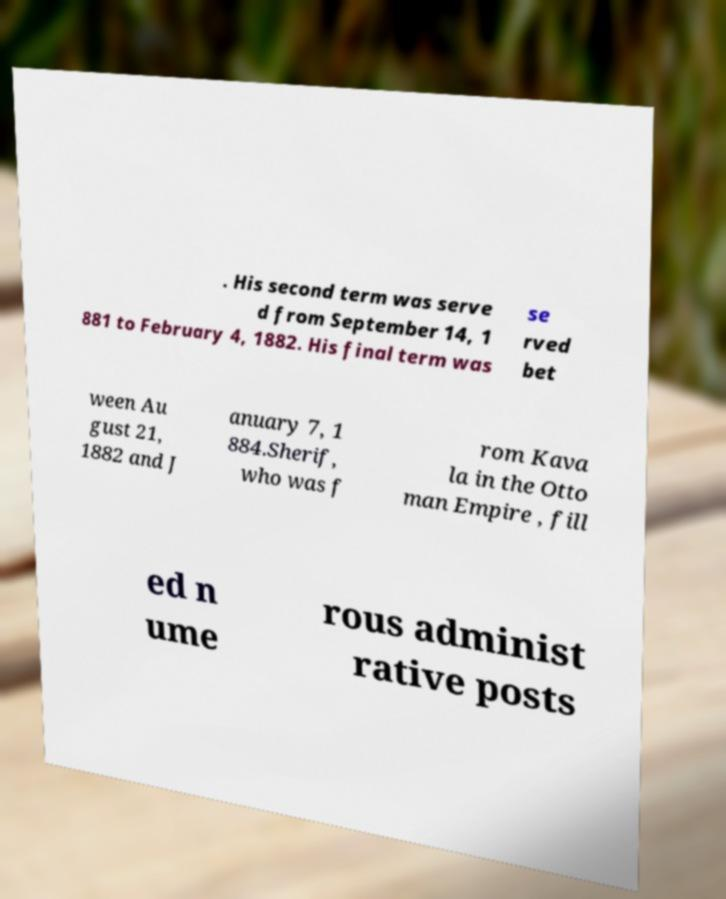Please identify and transcribe the text found in this image. . His second term was serve d from September 14, 1 881 to February 4, 1882. His final term was se rved bet ween Au gust 21, 1882 and J anuary 7, 1 884.Sherif, who was f rom Kava la in the Otto man Empire , fill ed n ume rous administ rative posts 